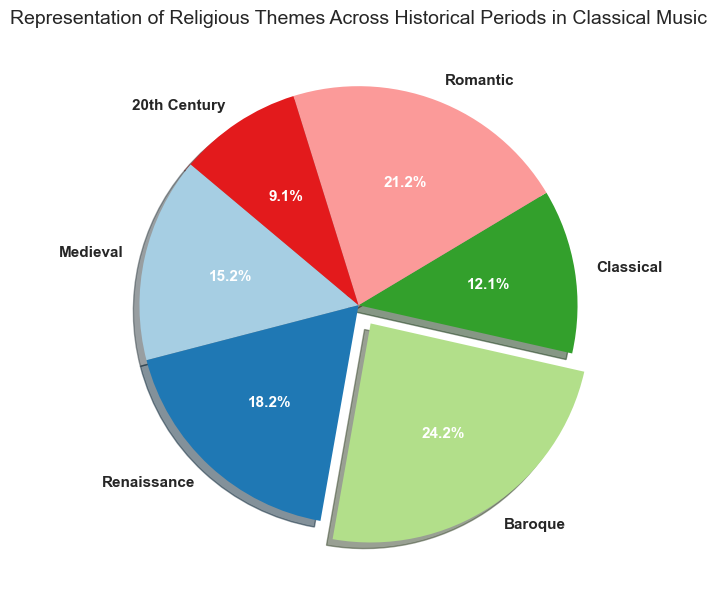What percentage of the musical periods represented religious themes above 30%? To find the percentage, identify periods where the representation is above 30%. These periods are Baroque (40%) and Romantic (35%). There are 2 out of 6 periods, so (2/6)*100 = 33.3%.
Answer: 33.3% Which period has the highest representation of religious themes and by how much does it exceed the lowest representation? The Baroque period has the highest representation at 40% and the 20th Century has the lowest at 15%. The difference is 40% - 15% = 25%.
Answer: 25% What's the total representation of religious themes for the Medieval and Renaissance periods combined? Sum the representations of Medieval (25%) and Renaissance (30%) periods. This gives 25% + 30% = 55%.
Answer: 55% How does the representation of religious themes in the Classical period compare to that in the Baroque period? The Classical period has 20% representation, while the Baroque period has 40%. Therefore, the Classical period's representation is 20% lower than the Baroque period’s.
Answer: 20% lower What is the average representation of religious themes across all periods? Sum up the percentages of all periods: 25% + 30% + 40% + 20% + 35% + 15% = 165%. Divide by the number of periods (6) to get 165%/6 = 27.5%.
Answer: 27.5% Which period's wedge is the largest in the pie chart and what color is it typically in the pie chart rendered by the given code? The Baroque period, with 40%, is the largest wedge. The pie chart uses the 'Paired' colormap, but without a figure to visually confirm, it's typically one of the distinct colors in the colormap (could be blue, green, etc.). Given the first stated color is arbitrary without viewing the chart, let's assume a prominent color from the 'Paired' palette.
Answer: Baroque, likely blue or green Is the data representation consistent across all periods, or is there a significant range in values? The values range from 15% to 40%, indicating significant variance. This can be observed from the lowest (20th Century, 15%) to the highest (Baroque, 40%), showing a 25% range.
Answer: Significant variance (25%) Which period shows a moderate representation of religious themes and is positioned between Medieval and Renaissance in terms of representation? The Romantic period shows a moderate representation of 35%, which is higher than Medieval (25%) but lower than Renaissance (30%).
Answer: Romantic Looking at the given data, what is a noteworthy difference between the Renaissance and 20th Century periods in terms of religious themes? The Renaissance period has a significantly higher representation at 30% compared to the 20th Century's 15%, showing a 15% difference.
Answer: 15% Can you identify which period's wedge might have an added emphasis (slightly separated from the pie chart) due to its higher value? The Baroque period, which has the highest representation at 40%, likely has an added emphasis through the explode effect, making its wedge appear slightly separated from the rest.
Answer: Baroque 